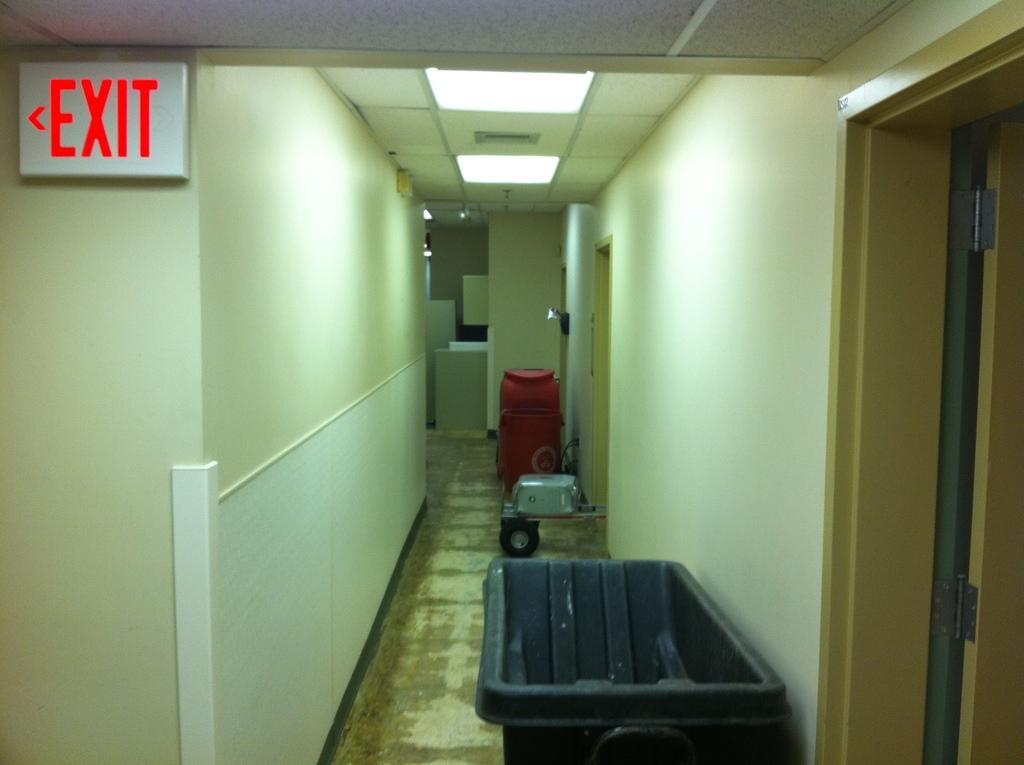Could you give a brief overview of what you see in this image? This is an inside view of a building. On the right side there is a door. On the left side, I can see an exit board to the wall. At the bottom of the image I can see a black color dustbin on the floor. In the background there is a red color drum and vehicle are placed on the floor. On the top I can see the lights. 